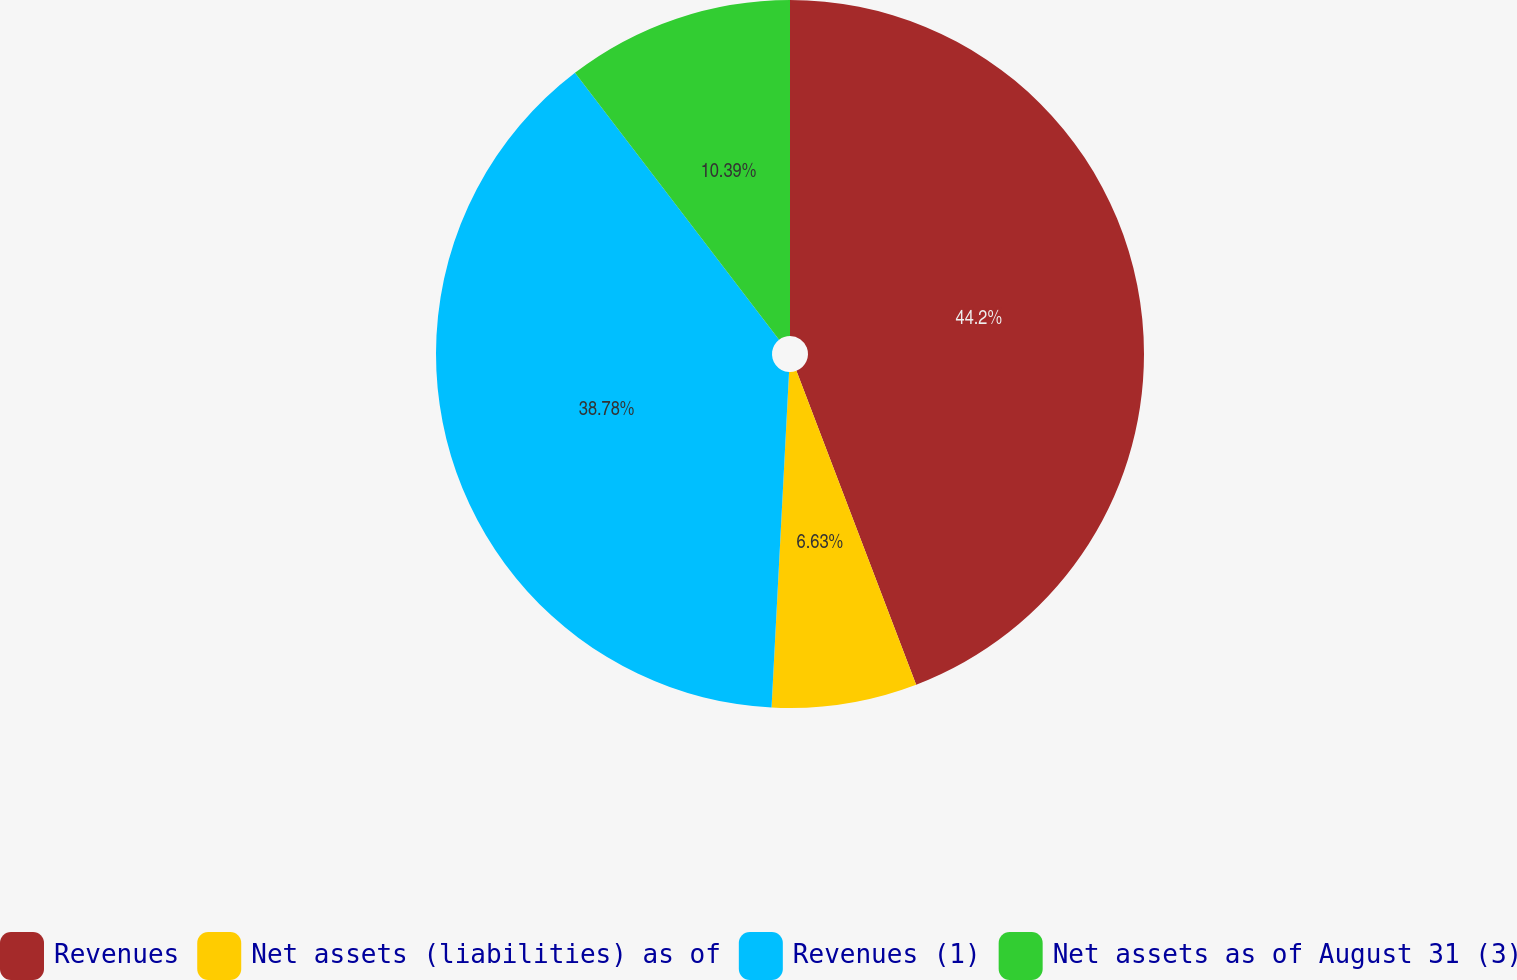Convert chart to OTSL. <chart><loc_0><loc_0><loc_500><loc_500><pie_chart><fcel>Revenues<fcel>Net assets (liabilities) as of<fcel>Revenues (1)<fcel>Net assets as of August 31 (3)<nl><fcel>44.2%<fcel>6.63%<fcel>38.78%<fcel>10.39%<nl></chart> 